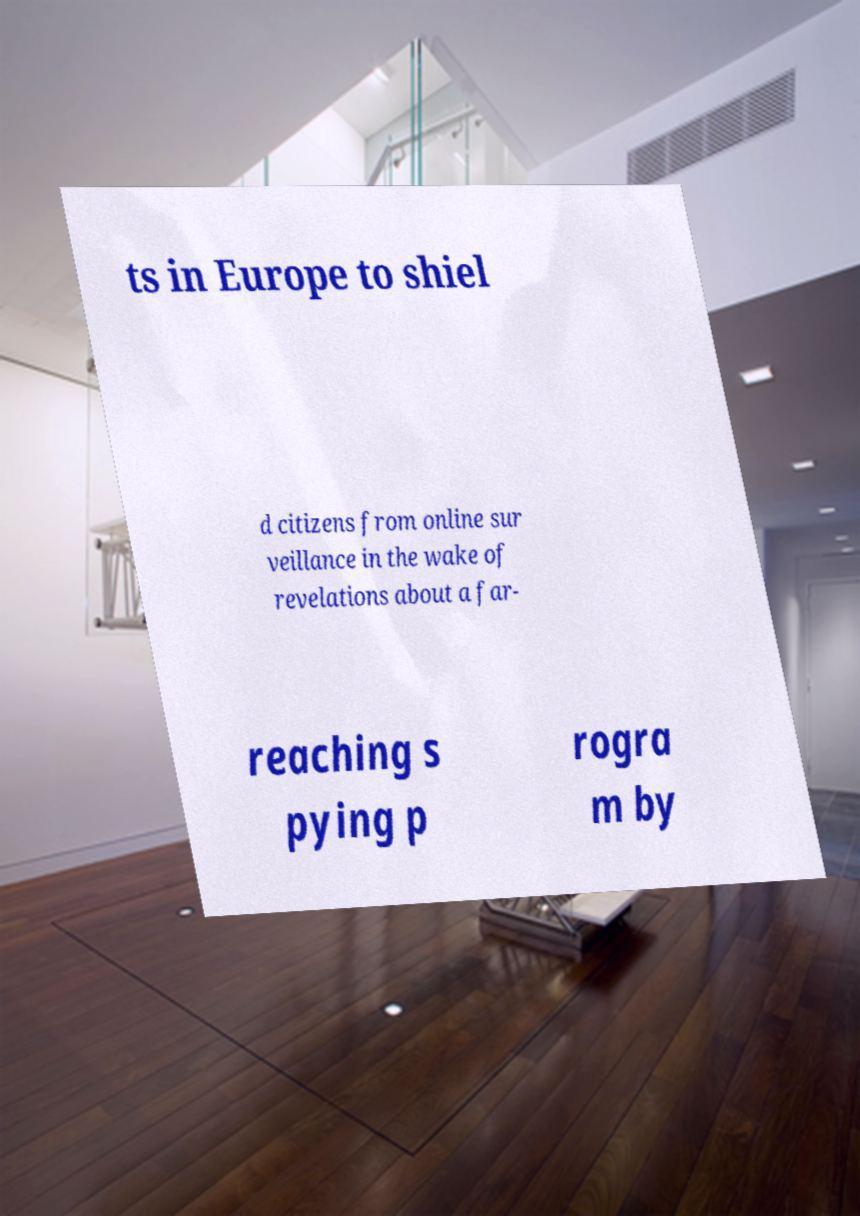Could you assist in decoding the text presented in this image and type it out clearly? ts in Europe to shiel d citizens from online sur veillance in the wake of revelations about a far- reaching s pying p rogra m by 